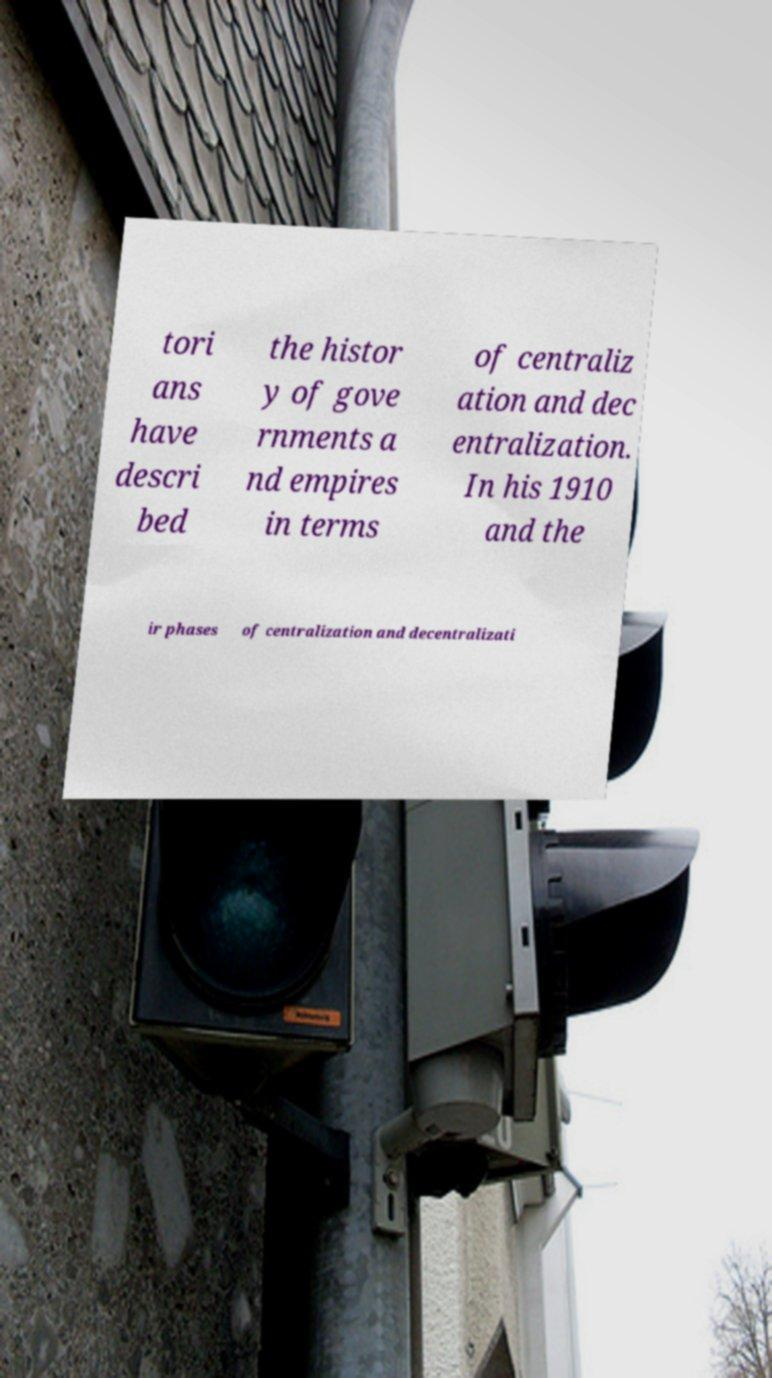Please identify and transcribe the text found in this image. tori ans have descri bed the histor y of gove rnments a nd empires in terms of centraliz ation and dec entralization. In his 1910 and the ir phases of centralization and decentralizati 